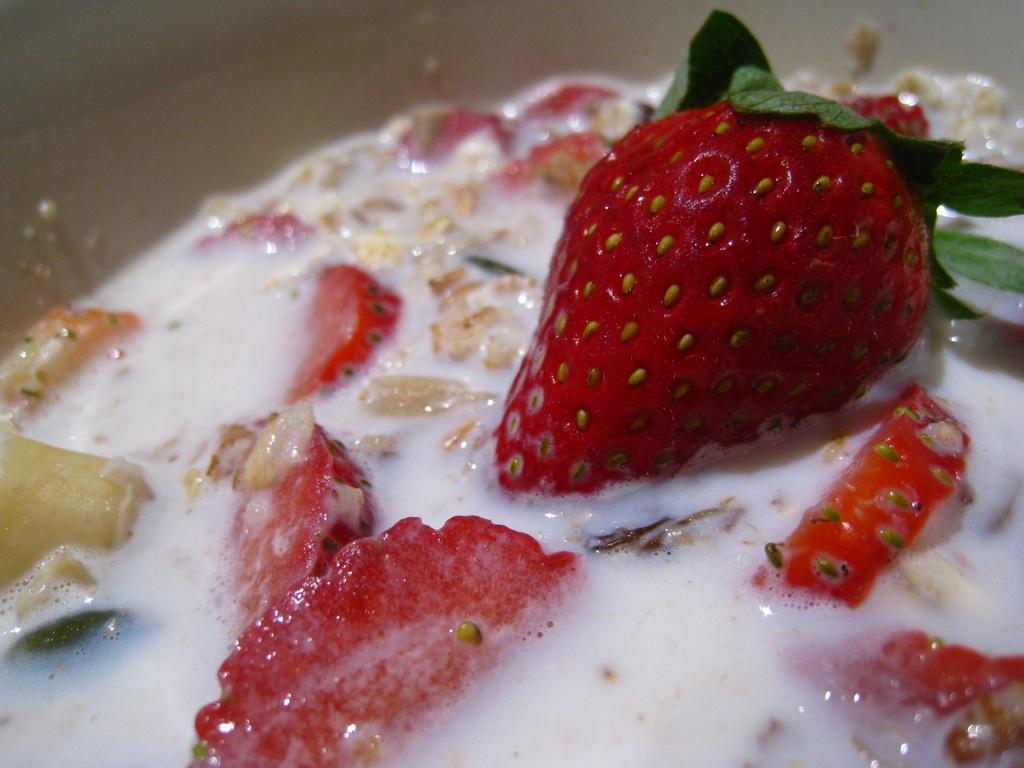Could you give a brief overview of what you see in this image? In this picture, we can see the strawberries and some other food items in an object. 